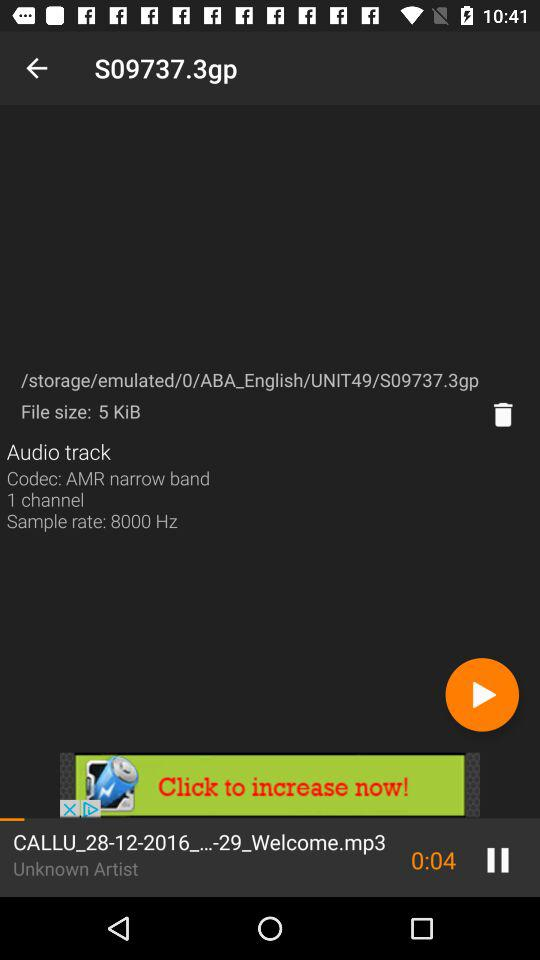Which song is currently playing? The song is "CALLU_28-12-2016_...-29_Welcome.mp3". 